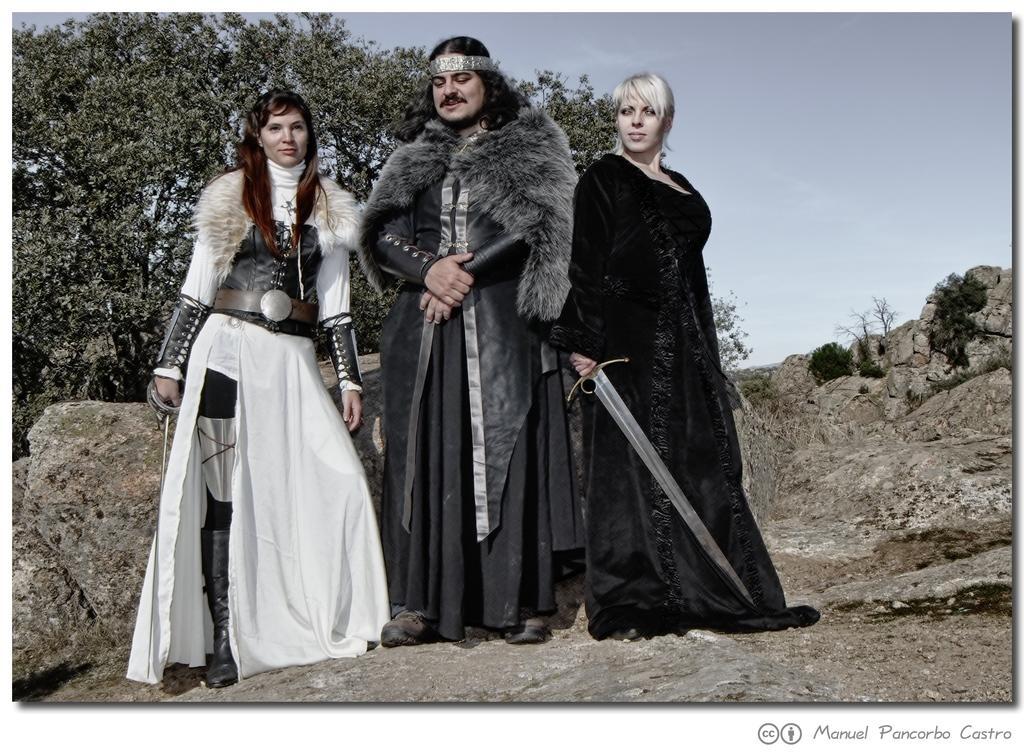In one or two sentences, can you explain what this image depicts? In this picture we can see three persons the middle one is the man and beside to him both are woman. This three persons were some customs and two women are holding sword and fence stick in their hand and in the background we can see trees, sky, rocks where these three persons are standing on that rock. 